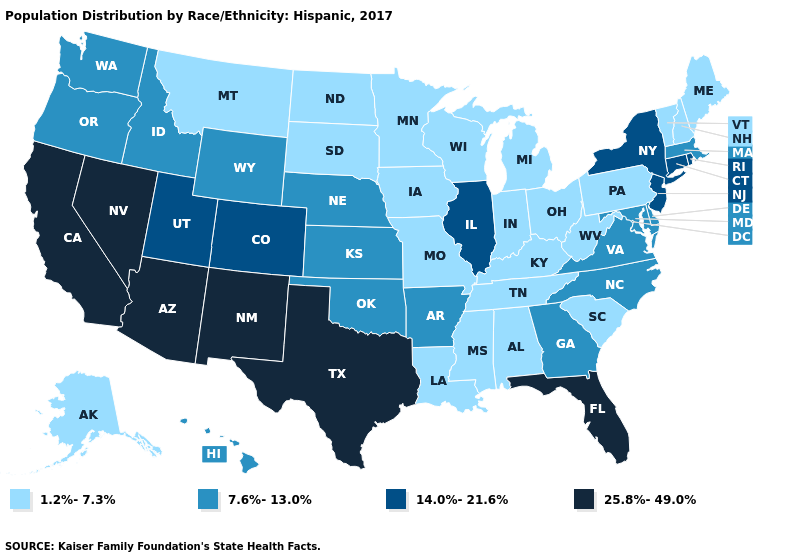Does the map have missing data?
Give a very brief answer. No. Does Maryland have the lowest value in the USA?
Concise answer only. No. Does Delaware have the highest value in the South?
Give a very brief answer. No. Does the map have missing data?
Keep it brief. No. Is the legend a continuous bar?
Give a very brief answer. No. Among the states that border Delaware , does New Jersey have the highest value?
Write a very short answer. Yes. Does Michigan have a lower value than Oregon?
Be succinct. Yes. Which states hav the highest value in the MidWest?
Concise answer only. Illinois. Name the states that have a value in the range 1.2%-7.3%?
Concise answer only. Alabama, Alaska, Indiana, Iowa, Kentucky, Louisiana, Maine, Michigan, Minnesota, Mississippi, Missouri, Montana, New Hampshire, North Dakota, Ohio, Pennsylvania, South Carolina, South Dakota, Tennessee, Vermont, West Virginia, Wisconsin. What is the value of Vermont?
Quick response, please. 1.2%-7.3%. Does the first symbol in the legend represent the smallest category?
Keep it brief. Yes. Among the states that border Massachusetts , does Connecticut have the highest value?
Quick response, please. Yes. Which states have the lowest value in the USA?
Answer briefly. Alabama, Alaska, Indiana, Iowa, Kentucky, Louisiana, Maine, Michigan, Minnesota, Mississippi, Missouri, Montana, New Hampshire, North Dakota, Ohio, Pennsylvania, South Carolina, South Dakota, Tennessee, Vermont, West Virginia, Wisconsin. What is the value of Minnesota?
Short answer required. 1.2%-7.3%. Among the states that border West Virginia , which have the lowest value?
Quick response, please. Kentucky, Ohio, Pennsylvania. 